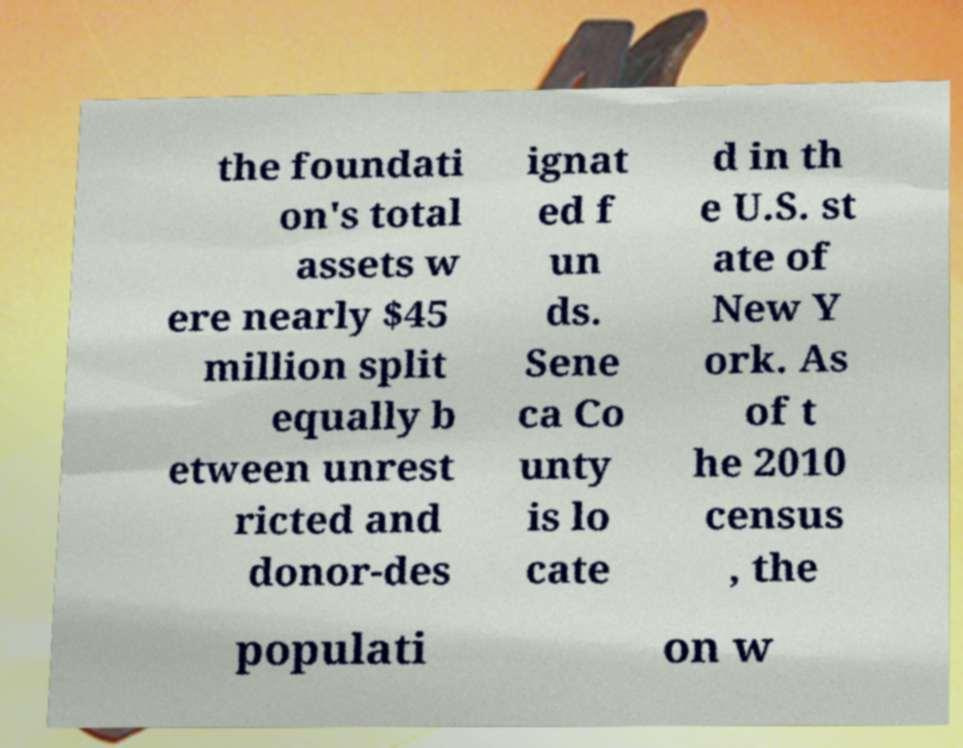There's text embedded in this image that I need extracted. Can you transcribe it verbatim? the foundati on's total assets w ere nearly $45 million split equally b etween unrest ricted and donor-des ignat ed f un ds. Sene ca Co unty is lo cate d in th e U.S. st ate of New Y ork. As of t he 2010 census , the populati on w 